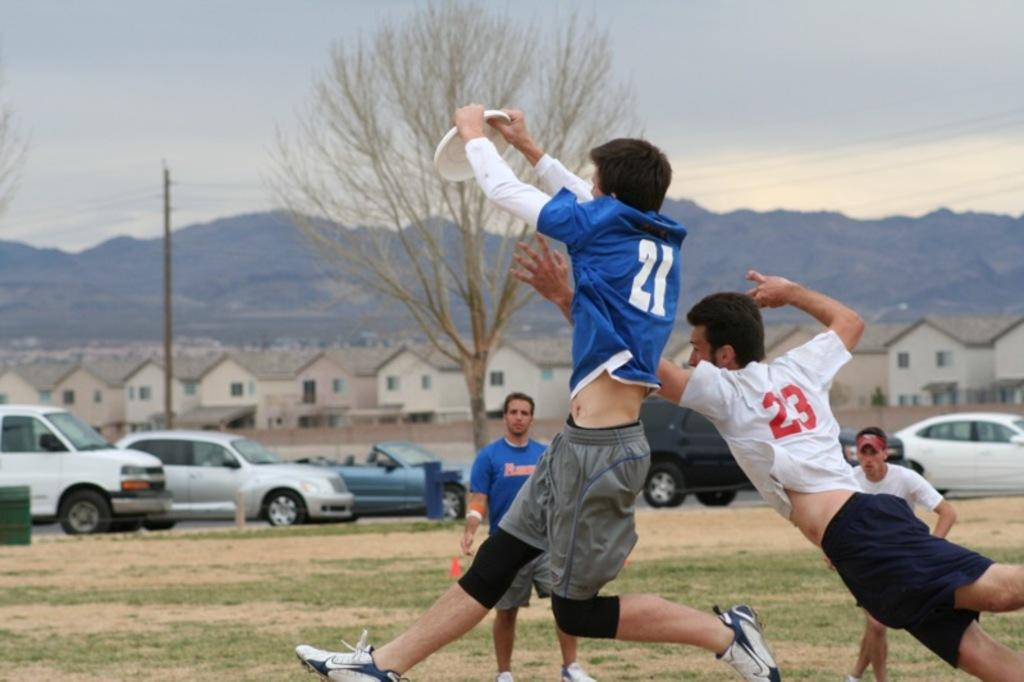How many people are playing Frisbee in the image? There are 4 people in the image. What activity are the people engaged in? The people are playing Frisbee. Where is the game taking place? The game is taking place on a grass area. What can be seen in the background of the image? There are vehicles, houses, and mountains visible in the background. How would you describe the sky in the image? The sky appears gloomy. What is the name of the daughter of the person playing Frisbee in the image? There is no mention of a daughter or any specific person in the image, so it is not possible to answer this question. 